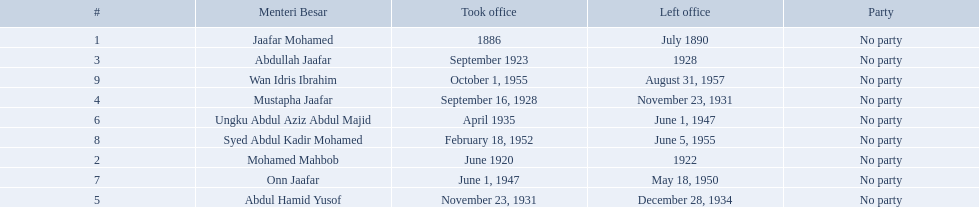When did jaafar mohamed take office? 1886. When did mohamed mahbob take office? June 1920. Who was in office no more than 4 years? Mohamed Mahbob. 